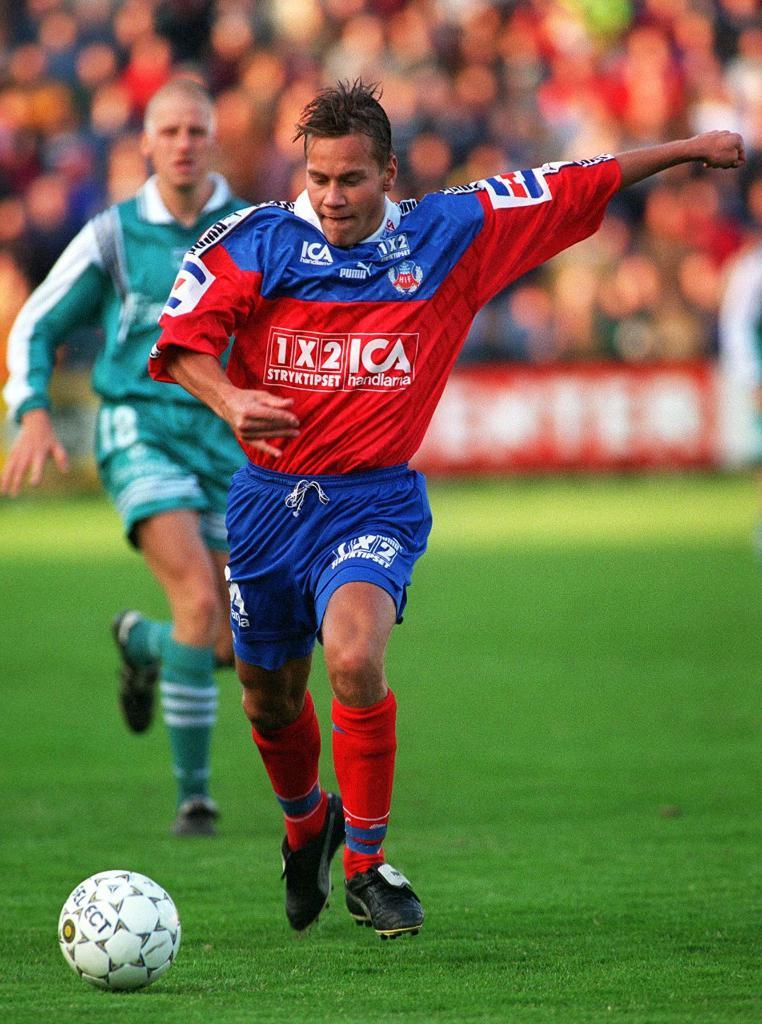How many people are in the image? There are two men in the image. What are the men doing in the image? The men are running on the ground. What object is present in the image besides the men? There is a ball in the image. Can you describe the background of the image? The background of the image is blurred. What type of curtain is hanging in the background of the image? There is no curtain present in the image; the background is blurred. Can you tell me the opinion of the worm in the image? There is no worm present in the image, so it is not possible to determine its opinion. 